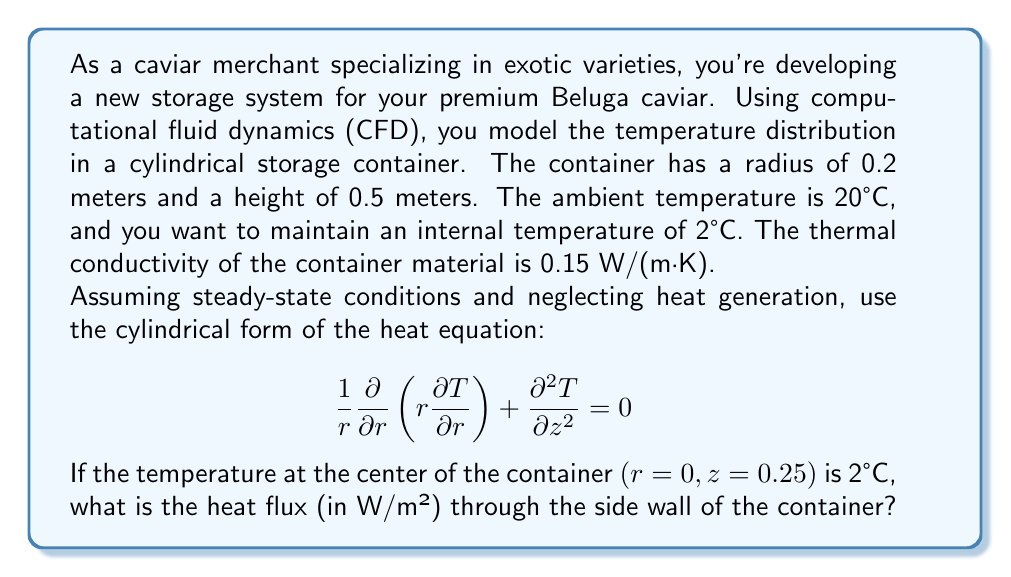Can you solve this math problem? To solve this problem, we'll use the cylindrical heat equation and apply the given boundary conditions. Let's approach this step-by-step:

1) Given the symmetry of the problem, we can assume that the temperature only varies with the radial coordinate $r$. This simplifies our equation to:

   $$ \frac{1}{r} \frac{d}{dr} \left(r \frac{dT}{dr}\right) = 0 $$

2) Integrating this equation twice, we get the general solution:

   $$ T(r) = C_1 \ln(r) + C_2 $$

3) We have two boundary conditions:
   - At $r=0$ (center), $T = 2°C$
   - At $r=0.2$ (wall), $T = 20°C$

4) Applying the first condition:
   $2 = C_1 \ln(0) + C_2$
   Since $\ln(0)$ is undefined, $C_1$ must be 0 for the solution to be valid at $r=0$.
   Therefore, $C_2 = 2$

5) Applying the second condition:
   $20 = 2 + C_1 \ln(0.2)$
   $C_1 = \frac{18}{\ln(0.2)} \approx -11.156$

6) Our temperature distribution is thus:

   $$ T(r) = -11.156 \ln(r) + 2 $$

7) To find the heat flux, we use Fourier's law:

   $$ q = -k \frac{dT}{dr} $$

   where $k$ is the thermal conductivity.

8) Differentiating our temperature distribution:

   $$ \frac{dT}{dr} = -\frac{11.156}{r} $$

9) At $r=0.2$ (the wall), the temperature gradient is:

   $$ \left.\frac{dT}{dr}\right|_{r=0.2} = -\frac{11.156}{0.2} = -55.78 \text{ K/m} $$

10) Finally, calculating the heat flux:

    $$ q = -k \frac{dT}{dr} = -(0.15 \text{ W/(m·K)})(-55.78 \text{ K/m}) = 8.367 \text{ W/m²} $$
Answer: The heat flux through the side wall of the container is approximately 8.37 W/m². 